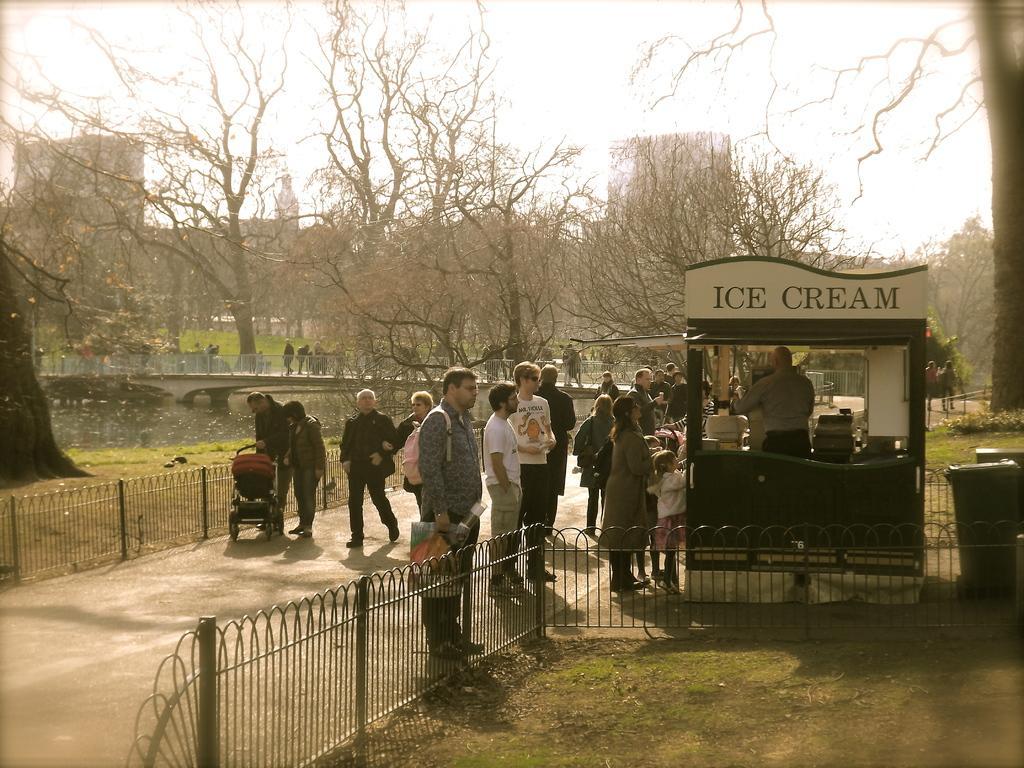How would you summarize this image in a sentence or two? Here in this picture on the right side we can see an ice cream shop present on the ground over there and we can see people standing and walking on the road over there and we can see railings present on either side and we can see the ground is fully covered with grass over there and we can also see plants and trees present all over there and in the far we can see buildings present over there. 